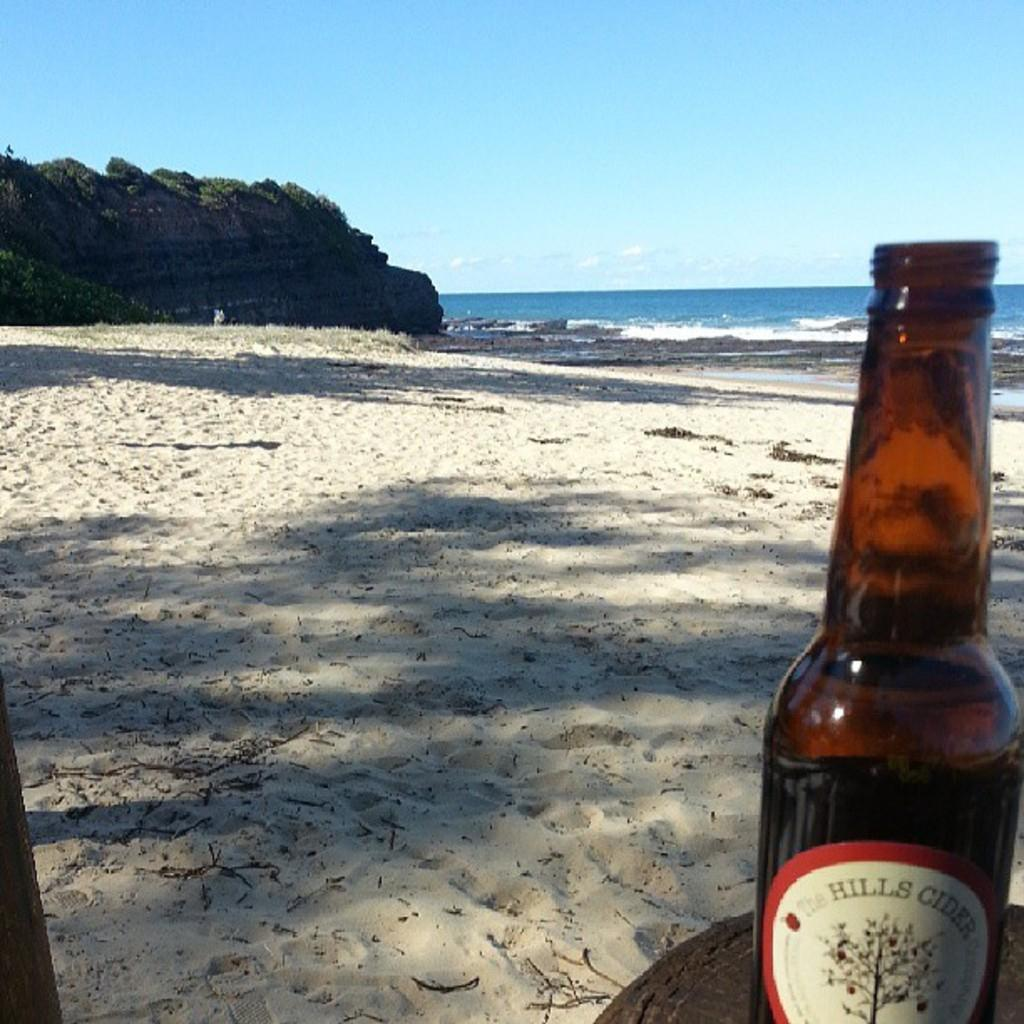<image>
Provide a brief description of the given image. A Hills Cider bottle is in the sand along the beach. 